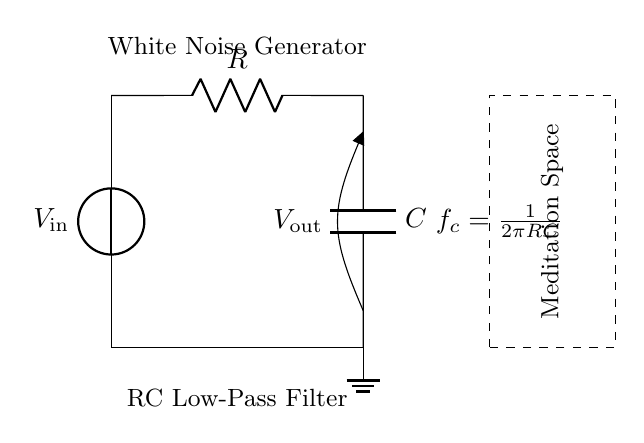What are the components of this RC low-pass filter? The circuit diagram shows a resistor and a capacitor connected in a specific configuration. These are the primary components of the RC low-pass filter.
Answer: Resistor and Capacitor What is the function of the voltage source in this circuit? The voltage source provides the input voltage, which is necessary for the circuit to operate. It supplies the electrical energy needed to generate the white noise.
Answer: Provides input voltage What does the cutoff frequency formula represent? The cutoff frequency formula indicates the frequency at which the output voltage is reduced to 70.7% of the input voltage, which is critical for determining how the circuit filters signals.
Answer: Frequency response What is the purpose of the dashed rectangle labeled "Meditation Space"? The dashed rectangle symbolizes the environment where the generated white noise will be utilized, specifically indicating that it is designed for a calming meditation setting.
Answer: Represents the meditation space How would increasing the resistance value affect the cutoff frequency? Increasing the resistance in the RC low-pass filter lowers the cutoff frequency, as indicated by the formula where frequency is inversely proportional to resistance.
Answer: Lowers cutoff frequency What type of signal is generated by this RC low-pass filter circuit? An RC low-pass filter circuit is designed to allow low-frequency signals to pass through while attenuating high-frequency signals, resulting in ambient white noise suitable for relaxation.
Answer: Ambient white noise What would happen to the output voltage if the capacitor is removed? Removing the capacitor would disrupt the low-pass filter function, leading to no filtering effect, and consequently, the output voltage would directly replicate the input voltage without attenuation of high frequencies.
Answer: No filtering effect 